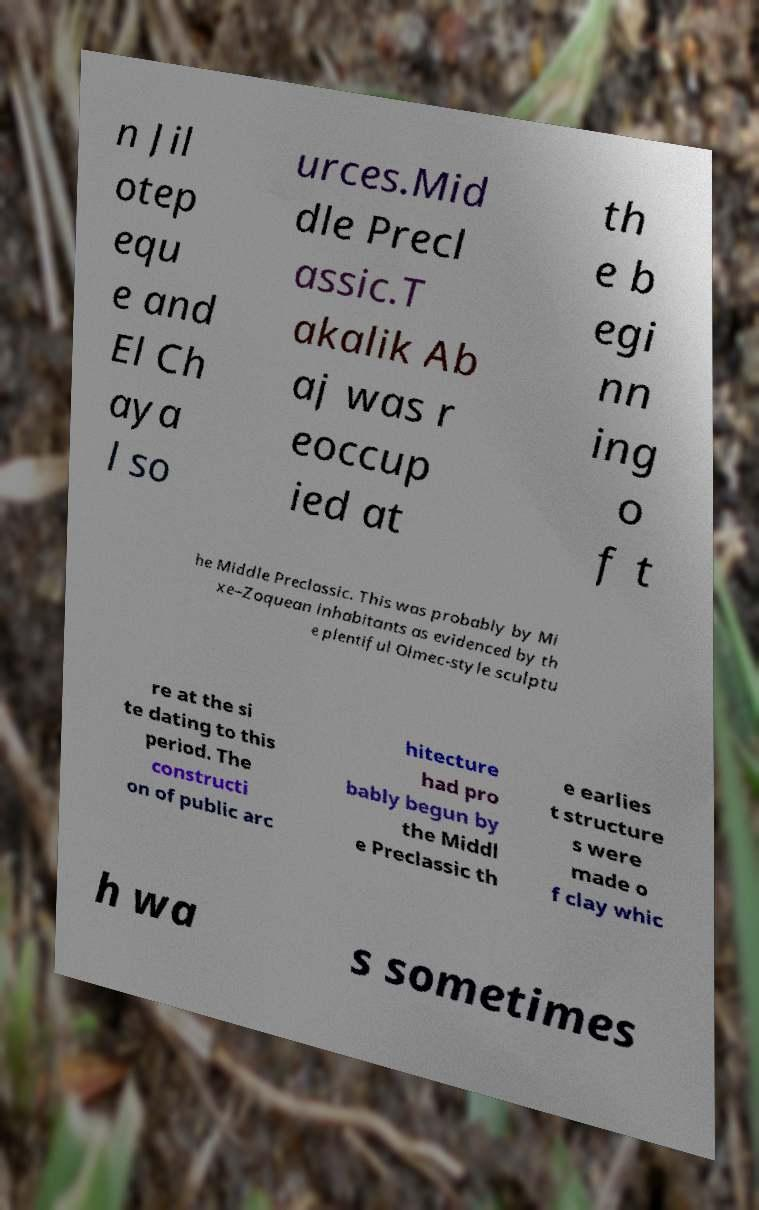Can you accurately transcribe the text from the provided image for me? n Jil otep equ e and El Ch aya l so urces.Mid dle Precl assic.T akalik Ab aj was r eoccup ied at th e b egi nn ing o f t he Middle Preclassic. This was probably by Mi xe–Zoquean inhabitants as evidenced by th e plentiful Olmec-style sculptu re at the si te dating to this period. The constructi on of public arc hitecture had pro bably begun by the Middl e Preclassic th e earlies t structure s were made o f clay whic h wa s sometimes 